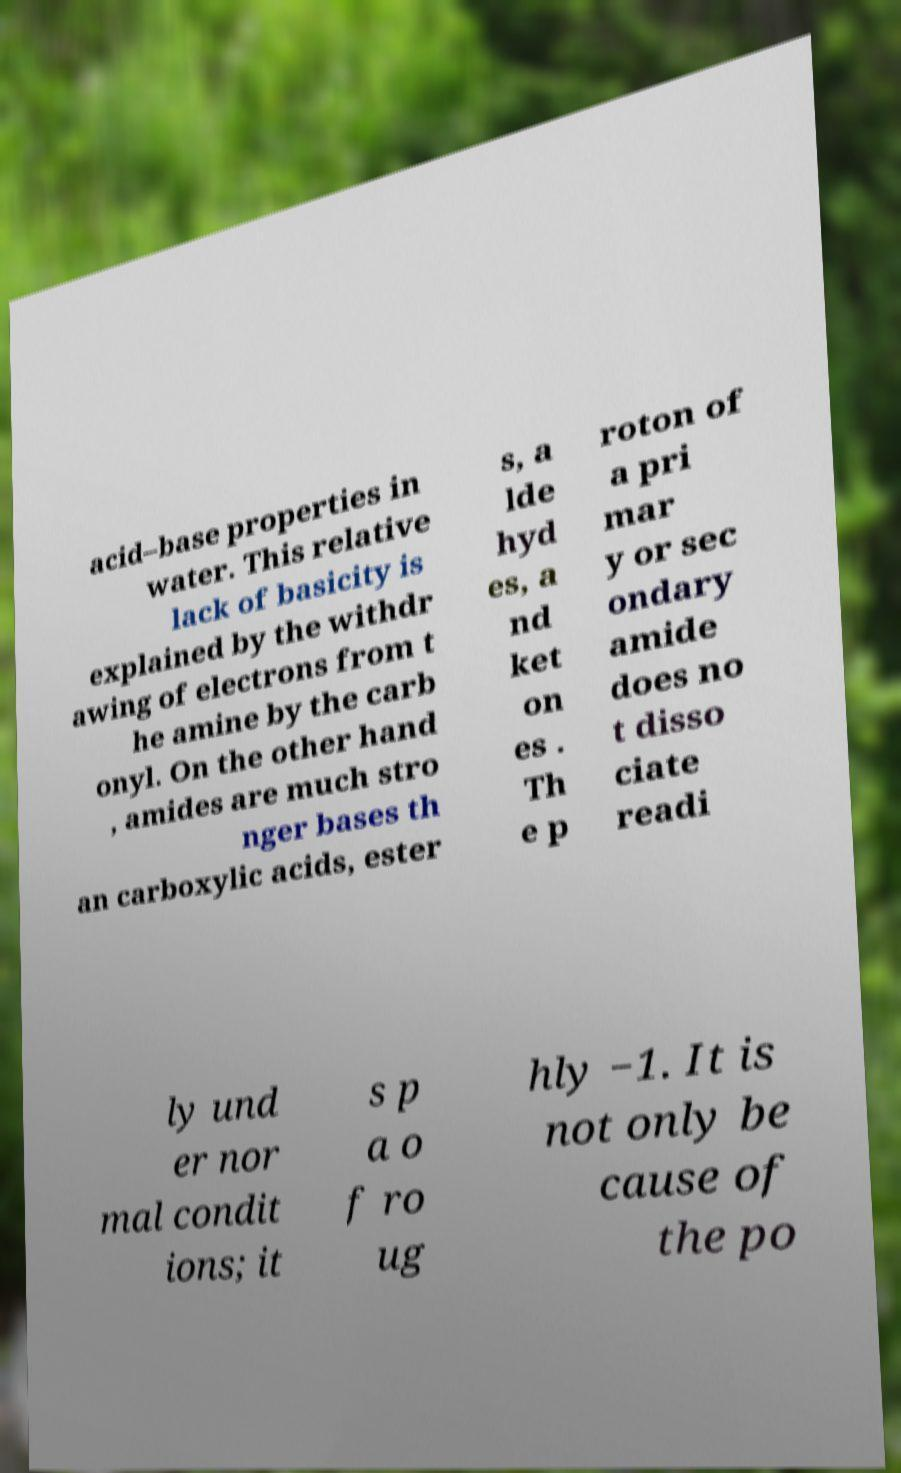Please identify and transcribe the text found in this image. acid–base properties in water. This relative lack of basicity is explained by the withdr awing of electrons from t he amine by the carb onyl. On the other hand , amides are much stro nger bases th an carboxylic acids, ester s, a lde hyd es, a nd ket on es . Th e p roton of a pri mar y or sec ondary amide does no t disso ciate readi ly und er nor mal condit ions; it s p a o f ro ug hly −1. It is not only be cause of the po 